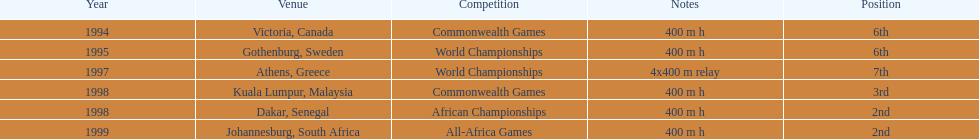What is the number of titles ken harden has one 6. 